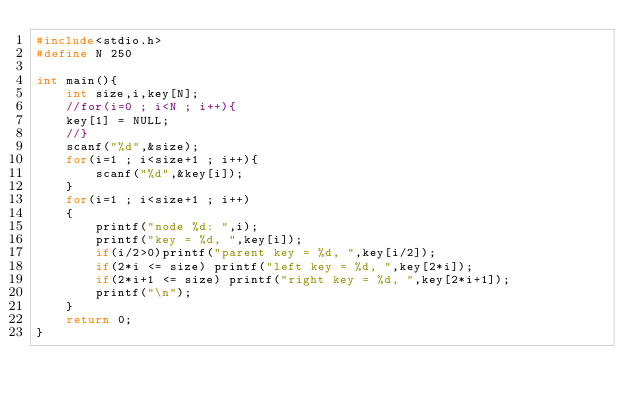<code> <loc_0><loc_0><loc_500><loc_500><_C_>#include<stdio.h>
#define N 250

int main(){
    int size,i,key[N];
    //for(i=0 ; i<N ; i++){
    key[1] = NULL;
    //}
    scanf("%d",&size);
    for(i=1 ; i<size+1 ; i++){
        scanf("%d",&key[i]);
    }
    for(i=1 ; i<size+1 ; i++)
    {
        printf("node %d: ",i);
        printf("key = %d, ",key[i]);
        if(i/2>0)printf("parent key = %d, ",key[i/2]);
        if(2*i <= size) printf("left key = %d, ",key[2*i]);
        if(2*i+1 <= size) printf("right key = %d, ",key[2*i+1]);
        printf("\n");
    }
    return 0;
}

</code> 